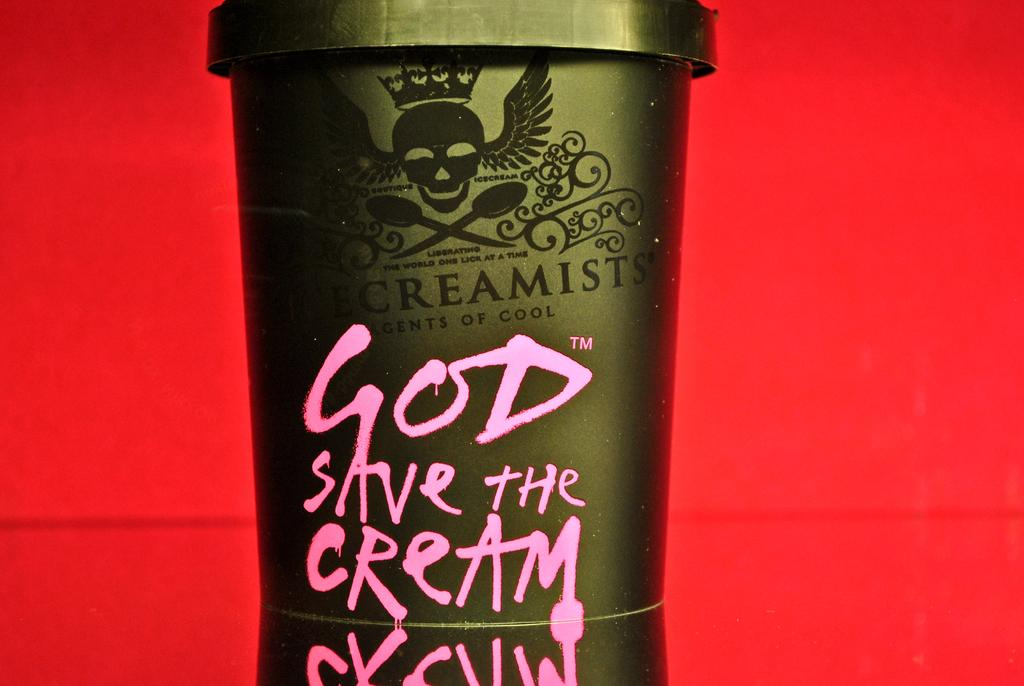<image>
Describe the image concisely. A container that has a skull with wings on it has "God save the Cream" written on it in pink letters. 